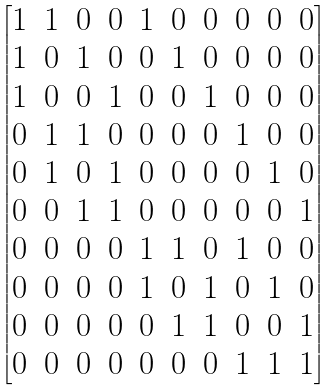<formula> <loc_0><loc_0><loc_500><loc_500>\begin{bmatrix} 1 & 1 & 0 & 0 & 1 & 0 & 0 & 0 & 0 & 0 \\ 1 & 0 & 1 & 0 & 0 & 1 & 0 & 0 & 0 & 0 \\ 1 & 0 & 0 & 1 & 0 & 0 & 1 & 0 & 0 & 0 \\ 0 & 1 & 1 & 0 & 0 & 0 & 0 & 1 & 0 & 0 \\ 0 & 1 & 0 & 1 & 0 & 0 & 0 & 0 & 1 & 0 \\ 0 & 0 & 1 & 1 & 0 & 0 & 0 & 0 & 0 & 1 \\ 0 & 0 & 0 & 0 & 1 & 1 & 0 & 1 & 0 & 0 \\ 0 & 0 & 0 & 0 & 1 & 0 & 1 & 0 & 1 & 0 \\ 0 & 0 & 0 & 0 & 0 & 1 & 1 & 0 & 0 & 1 \\ 0 & 0 & 0 & 0 & 0 & 0 & 0 & 1 & 1 & 1 \\ \end{bmatrix}</formula> 